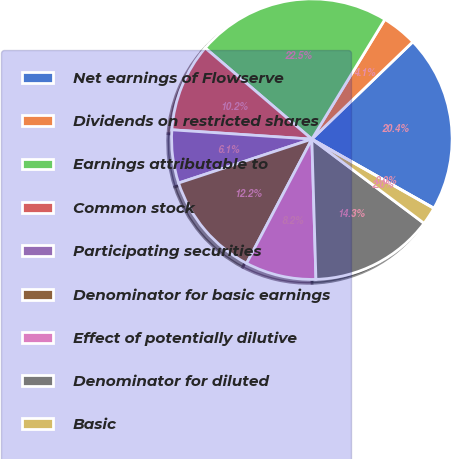Convert chart. <chart><loc_0><loc_0><loc_500><loc_500><pie_chart><fcel>Net earnings of Flowserve<fcel>Dividends on restricted shares<fcel>Earnings attributable to<fcel>Common stock<fcel>Participating securities<fcel>Denominator for basic earnings<fcel>Effect of potentially dilutive<fcel>Denominator for diluted<fcel>Basic<fcel>Diluted<nl><fcel>20.41%<fcel>4.08%<fcel>22.45%<fcel>10.2%<fcel>6.12%<fcel>12.24%<fcel>8.16%<fcel>14.29%<fcel>2.04%<fcel>0.0%<nl></chart> 